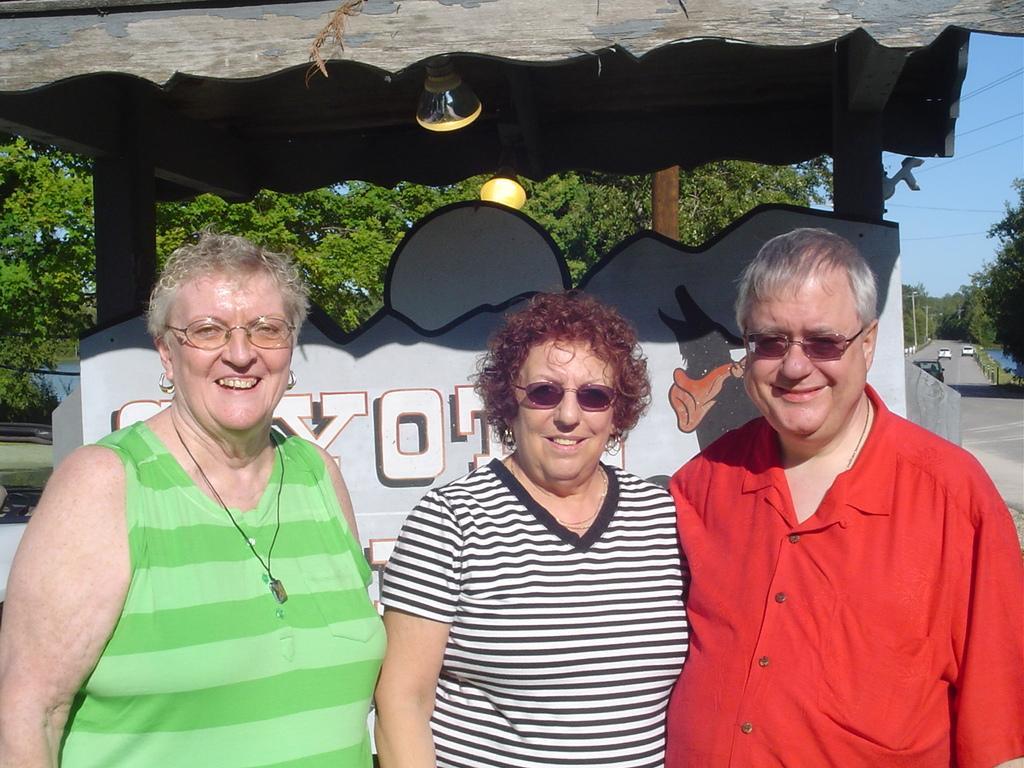Can you describe this image briefly? In the picture I can see a woman wearing green color dress and spectacles is standing on the left side of the image, we can see a woman wearing black and white color T-shirt and glasses is standing next to her and on the right side of the image, I can see a man wearing a red color shirt and glasses is standing. Here we can see they are all smiling and in the background, I can see a board, wooden pergola, lights, trees, vehicles moving on the road, I can see the poles, wires and the sky. 